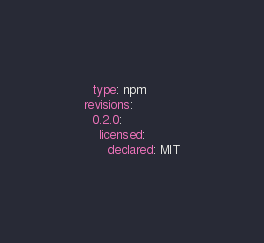Convert code to text. <code><loc_0><loc_0><loc_500><loc_500><_YAML_>  type: npm
revisions:
  0.2.0:
    licensed:
      declared: MIT
</code> 